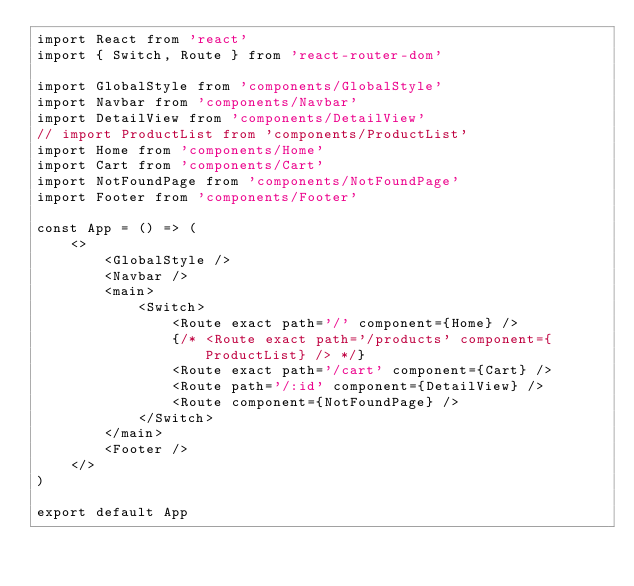<code> <loc_0><loc_0><loc_500><loc_500><_JavaScript_>import React from 'react'
import { Switch, Route } from 'react-router-dom'

import GlobalStyle from 'components/GlobalStyle'
import Navbar from 'components/Navbar'
import DetailView from 'components/DetailView'
// import ProductList from 'components/ProductList'
import Home from 'components/Home'
import Cart from 'components/Cart'
import NotFoundPage from 'components/NotFoundPage'
import Footer from 'components/Footer'

const App = () => (
	<>
		<GlobalStyle />
		<Navbar />
		<main>
			<Switch>
				<Route exact path='/' component={Home} />
				{/* <Route exact path='/products' component={ProductList} /> */}
				<Route exact path='/cart' component={Cart} />
				<Route path='/:id' component={DetailView} />
				<Route component={NotFoundPage} />
			</Switch>
		</main>
		<Footer />
	</>
)

export default App
</code> 